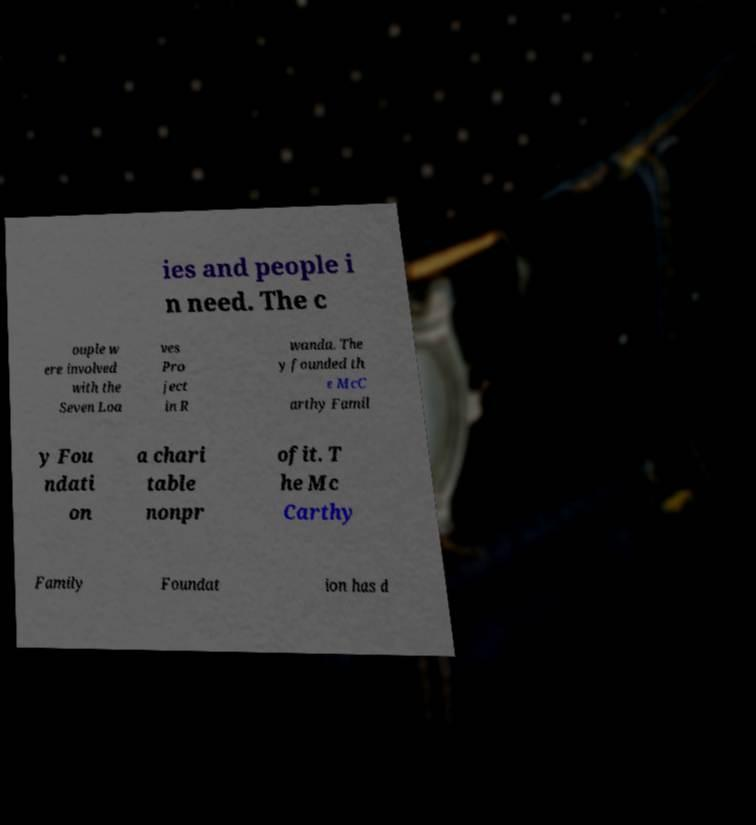Please identify and transcribe the text found in this image. ies and people i n need. The c ouple w ere involved with the Seven Loa ves Pro ject in R wanda. The y founded th e McC arthy Famil y Fou ndati on a chari table nonpr ofit. T he Mc Carthy Family Foundat ion has d 